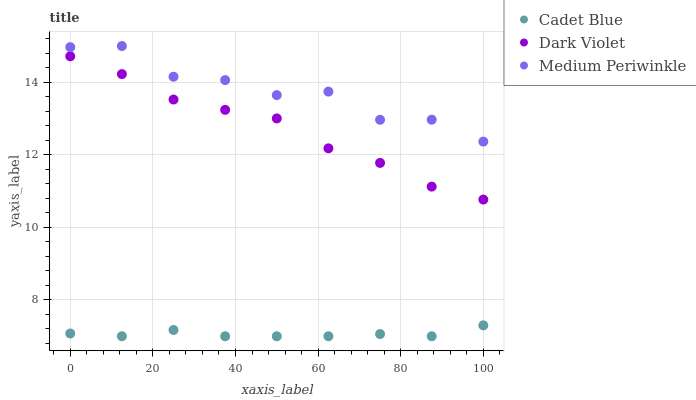Does Cadet Blue have the minimum area under the curve?
Answer yes or no. Yes. Does Medium Periwinkle have the maximum area under the curve?
Answer yes or no. Yes. Does Dark Violet have the minimum area under the curve?
Answer yes or no. No. Does Dark Violet have the maximum area under the curve?
Answer yes or no. No. Is Cadet Blue the smoothest?
Answer yes or no. Yes. Is Medium Periwinkle the roughest?
Answer yes or no. Yes. Is Dark Violet the smoothest?
Answer yes or no. No. Is Dark Violet the roughest?
Answer yes or no. No. Does Cadet Blue have the lowest value?
Answer yes or no. Yes. Does Dark Violet have the lowest value?
Answer yes or no. No. Does Medium Periwinkle have the highest value?
Answer yes or no. Yes. Does Dark Violet have the highest value?
Answer yes or no. No. Is Cadet Blue less than Medium Periwinkle?
Answer yes or no. Yes. Is Medium Periwinkle greater than Dark Violet?
Answer yes or no. Yes. Does Cadet Blue intersect Medium Periwinkle?
Answer yes or no. No. 